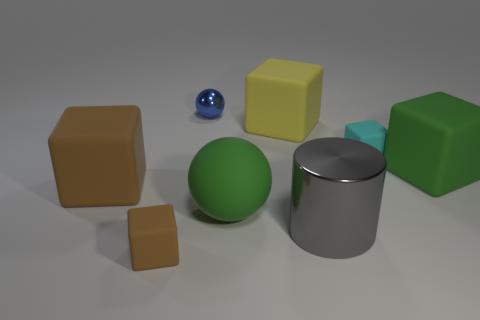There is a big block that is to the right of the yellow matte thing; is it the same color as the sphere in front of the blue shiny thing?
Your answer should be very brief. Yes. There is a brown matte thing on the left side of the small block to the left of the tiny blue metal object; how many large brown blocks are in front of it?
Ensure brevity in your answer.  0. There is a green block that is made of the same material as the cyan cube; what size is it?
Provide a succinct answer. Large. Does the sphere behind the yellow thing have the same size as the large gray thing?
Your answer should be compact. No. There is a small thing that is both to the right of the tiny brown block and in front of the tiny shiny object; what is its color?
Provide a short and direct response. Cyan. There is a brown block that is in front of the big rubber cube that is in front of the green matte thing that is on the right side of the large gray object; what is its material?
Provide a short and direct response. Rubber. There is a large rubber object on the right side of the shiny cylinder; is it the same color as the large sphere?
Give a very brief answer. Yes. Do the tiny brown thing and the large gray cylinder have the same material?
Make the answer very short. No. The large block that is on the left side of the green matte cube and to the right of the big rubber sphere is made of what material?
Your answer should be very brief. Rubber. What is the color of the small cube right of the tiny blue thing?
Your answer should be compact. Cyan. 